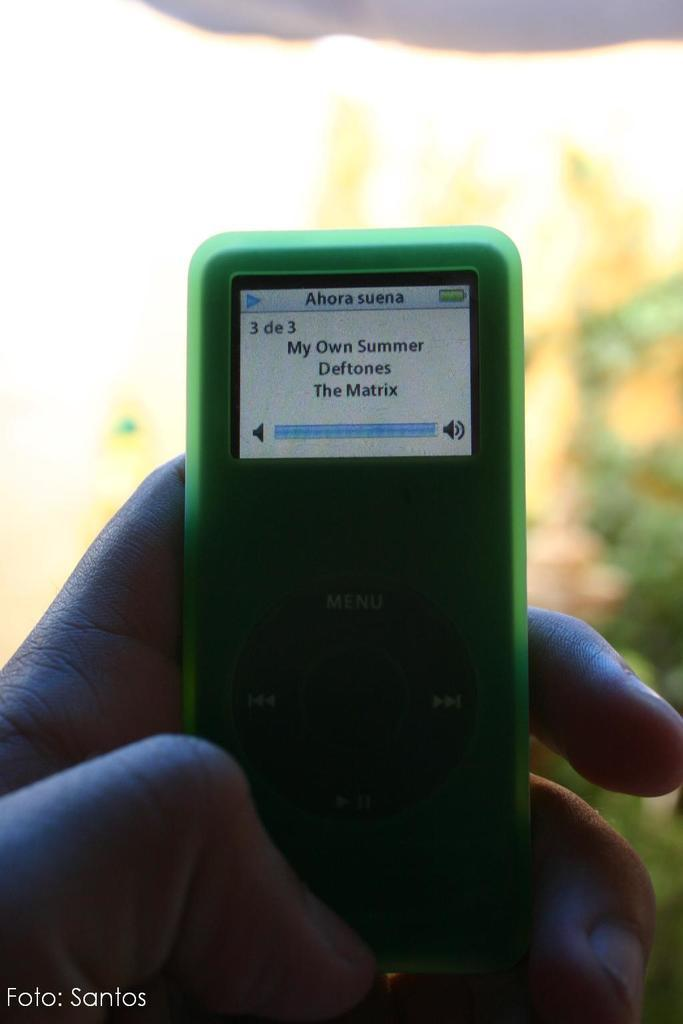What is the person holding in the image? There is a person's hand holding an iPod in the image. What can be said about the color of the iPod? The iPod is green in color. What features are present on the iPod? The iPod has buttons and a display. Where is the grandfather sitting in the image? There is no grandfather present in the image. What type of industry is depicted in the image? The image does not depict any industry; it features a person's hand holding an iPod. 